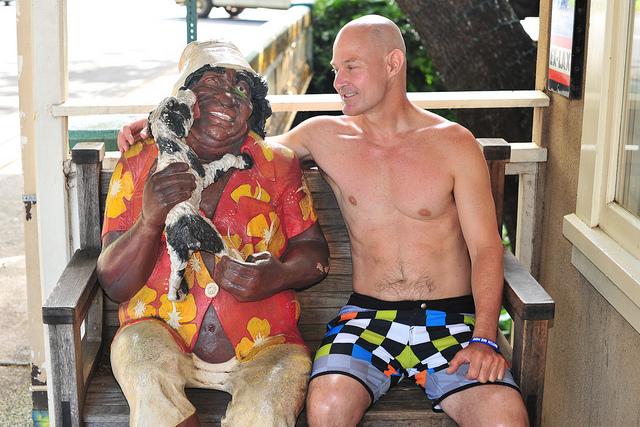Who has been on the bench longer?
Write a very short answer. Man on left. What is licking his face?
Concise answer only. Dog. Does this man have a sense of humor?
Keep it brief. Yes. 